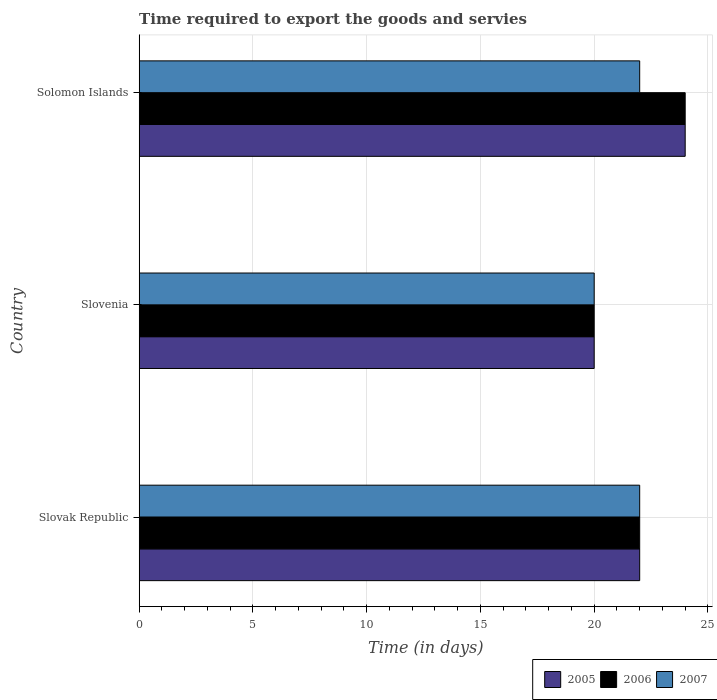Are the number of bars on each tick of the Y-axis equal?
Offer a very short reply. Yes. How many bars are there on the 3rd tick from the top?
Your response must be concise. 3. How many bars are there on the 1st tick from the bottom?
Provide a short and direct response. 3. What is the label of the 1st group of bars from the top?
Ensure brevity in your answer.  Solomon Islands. In how many cases, is the number of bars for a given country not equal to the number of legend labels?
Provide a succinct answer. 0. Across all countries, what is the maximum number of days required to export the goods and services in 2005?
Provide a succinct answer. 24. In which country was the number of days required to export the goods and services in 2005 maximum?
Provide a short and direct response. Solomon Islands. In which country was the number of days required to export the goods and services in 2007 minimum?
Your answer should be compact. Slovenia. What is the difference between the number of days required to export the goods and services in 2006 in Slovak Republic and that in Solomon Islands?
Give a very brief answer. -2. What is the difference between the number of days required to export the goods and services in 2005 in Slovak Republic and the number of days required to export the goods and services in 2007 in Solomon Islands?
Make the answer very short. 0. What is the average number of days required to export the goods and services in 2007 per country?
Offer a very short reply. 21.33. What is the difference between the number of days required to export the goods and services in 2006 and number of days required to export the goods and services in 2005 in Slovak Republic?
Your response must be concise. 0. What is the ratio of the number of days required to export the goods and services in 2006 in Slovenia to that in Solomon Islands?
Offer a terse response. 0.83. Is the difference between the number of days required to export the goods and services in 2006 in Slovak Republic and Slovenia greater than the difference between the number of days required to export the goods and services in 2005 in Slovak Republic and Slovenia?
Give a very brief answer. No. What is the difference between the highest and the second highest number of days required to export the goods and services in 2007?
Your answer should be very brief. 0. What is the difference between the highest and the lowest number of days required to export the goods and services in 2007?
Your answer should be very brief. 2. Is it the case that in every country, the sum of the number of days required to export the goods and services in 2005 and number of days required to export the goods and services in 2006 is greater than the number of days required to export the goods and services in 2007?
Your response must be concise. Yes. How many bars are there?
Your answer should be very brief. 9. What is the difference between two consecutive major ticks on the X-axis?
Offer a very short reply. 5. Does the graph contain any zero values?
Your answer should be very brief. No. Where does the legend appear in the graph?
Provide a short and direct response. Bottom right. What is the title of the graph?
Your response must be concise. Time required to export the goods and servies. Does "2002" appear as one of the legend labels in the graph?
Your answer should be compact. No. What is the label or title of the X-axis?
Give a very brief answer. Time (in days). What is the Time (in days) of 2005 in Slovak Republic?
Give a very brief answer. 22. What is the Time (in days) in 2007 in Slovak Republic?
Offer a terse response. 22. What is the Time (in days) in 2005 in Slovenia?
Ensure brevity in your answer.  20. Across all countries, what is the maximum Time (in days) of 2005?
Keep it short and to the point. 24. Across all countries, what is the maximum Time (in days) in 2006?
Make the answer very short. 24. Across all countries, what is the maximum Time (in days) of 2007?
Your answer should be compact. 22. Across all countries, what is the minimum Time (in days) in 2005?
Provide a short and direct response. 20. Across all countries, what is the minimum Time (in days) of 2006?
Your response must be concise. 20. Across all countries, what is the minimum Time (in days) in 2007?
Offer a terse response. 20. What is the total Time (in days) in 2006 in the graph?
Make the answer very short. 66. What is the total Time (in days) of 2007 in the graph?
Make the answer very short. 64. What is the difference between the Time (in days) in 2005 in Slovak Republic and that in Slovenia?
Provide a succinct answer. 2. What is the difference between the Time (in days) of 2007 in Slovak Republic and that in Slovenia?
Offer a terse response. 2. What is the difference between the Time (in days) of 2006 in Slovak Republic and that in Solomon Islands?
Provide a short and direct response. -2. What is the difference between the Time (in days) in 2006 in Slovenia and that in Solomon Islands?
Your answer should be compact. -4. What is the difference between the Time (in days) in 2005 in Slovak Republic and the Time (in days) in 2006 in Slovenia?
Your answer should be compact. 2. What is the difference between the Time (in days) of 2005 in Slovak Republic and the Time (in days) of 2007 in Solomon Islands?
Provide a succinct answer. 0. What is the difference between the Time (in days) in 2005 in Slovenia and the Time (in days) in 2006 in Solomon Islands?
Provide a short and direct response. -4. What is the difference between the Time (in days) of 2006 in Slovenia and the Time (in days) of 2007 in Solomon Islands?
Your answer should be compact. -2. What is the average Time (in days) in 2005 per country?
Make the answer very short. 22. What is the average Time (in days) in 2006 per country?
Your answer should be very brief. 22. What is the average Time (in days) of 2007 per country?
Make the answer very short. 21.33. What is the difference between the Time (in days) in 2005 and Time (in days) in 2007 in Slovak Republic?
Give a very brief answer. 0. What is the difference between the Time (in days) of 2005 and Time (in days) of 2006 in Slovenia?
Ensure brevity in your answer.  0. What is the difference between the Time (in days) in 2006 and Time (in days) in 2007 in Slovenia?
Keep it short and to the point. 0. What is the difference between the Time (in days) in 2005 and Time (in days) in 2006 in Solomon Islands?
Keep it short and to the point. 0. What is the difference between the Time (in days) of 2006 and Time (in days) of 2007 in Solomon Islands?
Ensure brevity in your answer.  2. What is the ratio of the Time (in days) of 2005 in Slovak Republic to that in Slovenia?
Your response must be concise. 1.1. What is the ratio of the Time (in days) in 2007 in Slovak Republic to that in Slovenia?
Offer a very short reply. 1.1. What is the ratio of the Time (in days) in 2006 in Slovak Republic to that in Solomon Islands?
Your answer should be compact. 0.92. What is the difference between the highest and the second highest Time (in days) in 2006?
Give a very brief answer. 2. What is the difference between the highest and the lowest Time (in days) of 2006?
Keep it short and to the point. 4. 